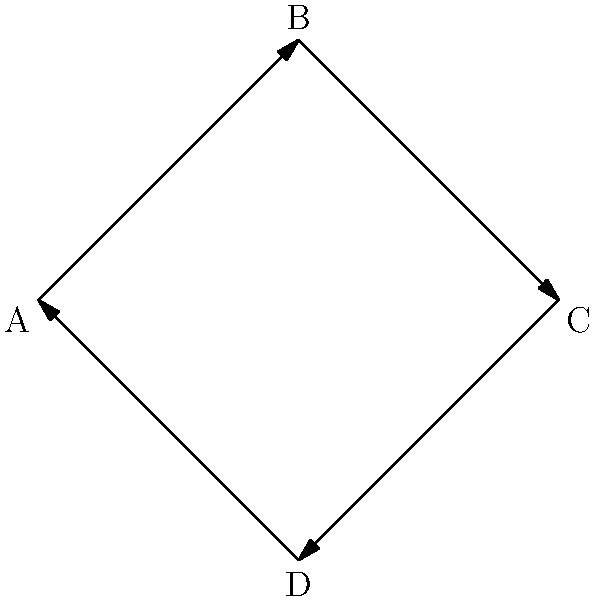In the financial transaction network depicted above, each node represents a subsidiary company, and each directed edge represents a cyclic flow of funds. If this network forms a cyclic group under the operation of fund transfer, what is the order of the generator element, and how many unique subgroups does this cyclic group have? To solve this problem, we need to follow these steps:

1. Identify the structure of the group:
   The diagram shows a cycle with 4 vertices (A, B, C, D) connected by directed edges, forming a cyclic group of order 4.

2. Determine the order of the generator element:
   In a cyclic group, the order of the generator element is equal to the order of the group itself. Here, the order is 4.

3. Calculate the number of unique subgroups:
   In a cyclic group of order n, the number of unique subgroups is equal to the number of divisors of n.
   The divisors of 4 are 1, 2, and 4.

4. Identify the subgroups:
   - Subgroup of order 1: {e} (identity element)
   - Subgroup of order 2: {e, a^2} where a is the generator
   - Subgroup of order 4: The entire group {e, a, a^2, a^3}

Therefore, the order of the generator element is 4, and the number of unique subgroups is 3.
Answer: Order of generator: 4; Number of unique subgroups: 3 